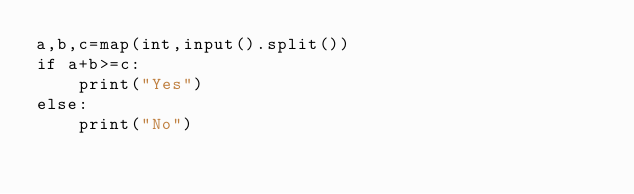Convert code to text. <code><loc_0><loc_0><loc_500><loc_500><_Python_>a,b,c=map(int,input().split())
if a+b>=c:
    print("Yes")
else:
    print("No")</code> 